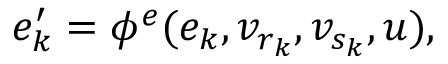<formula> <loc_0><loc_0><loc_500><loc_500>e _ { k } ^ { \prime } = \phi ^ { e } ( e _ { k } , v _ { r _ { k } } , v _ { s _ { k } } , u ) ,</formula> 